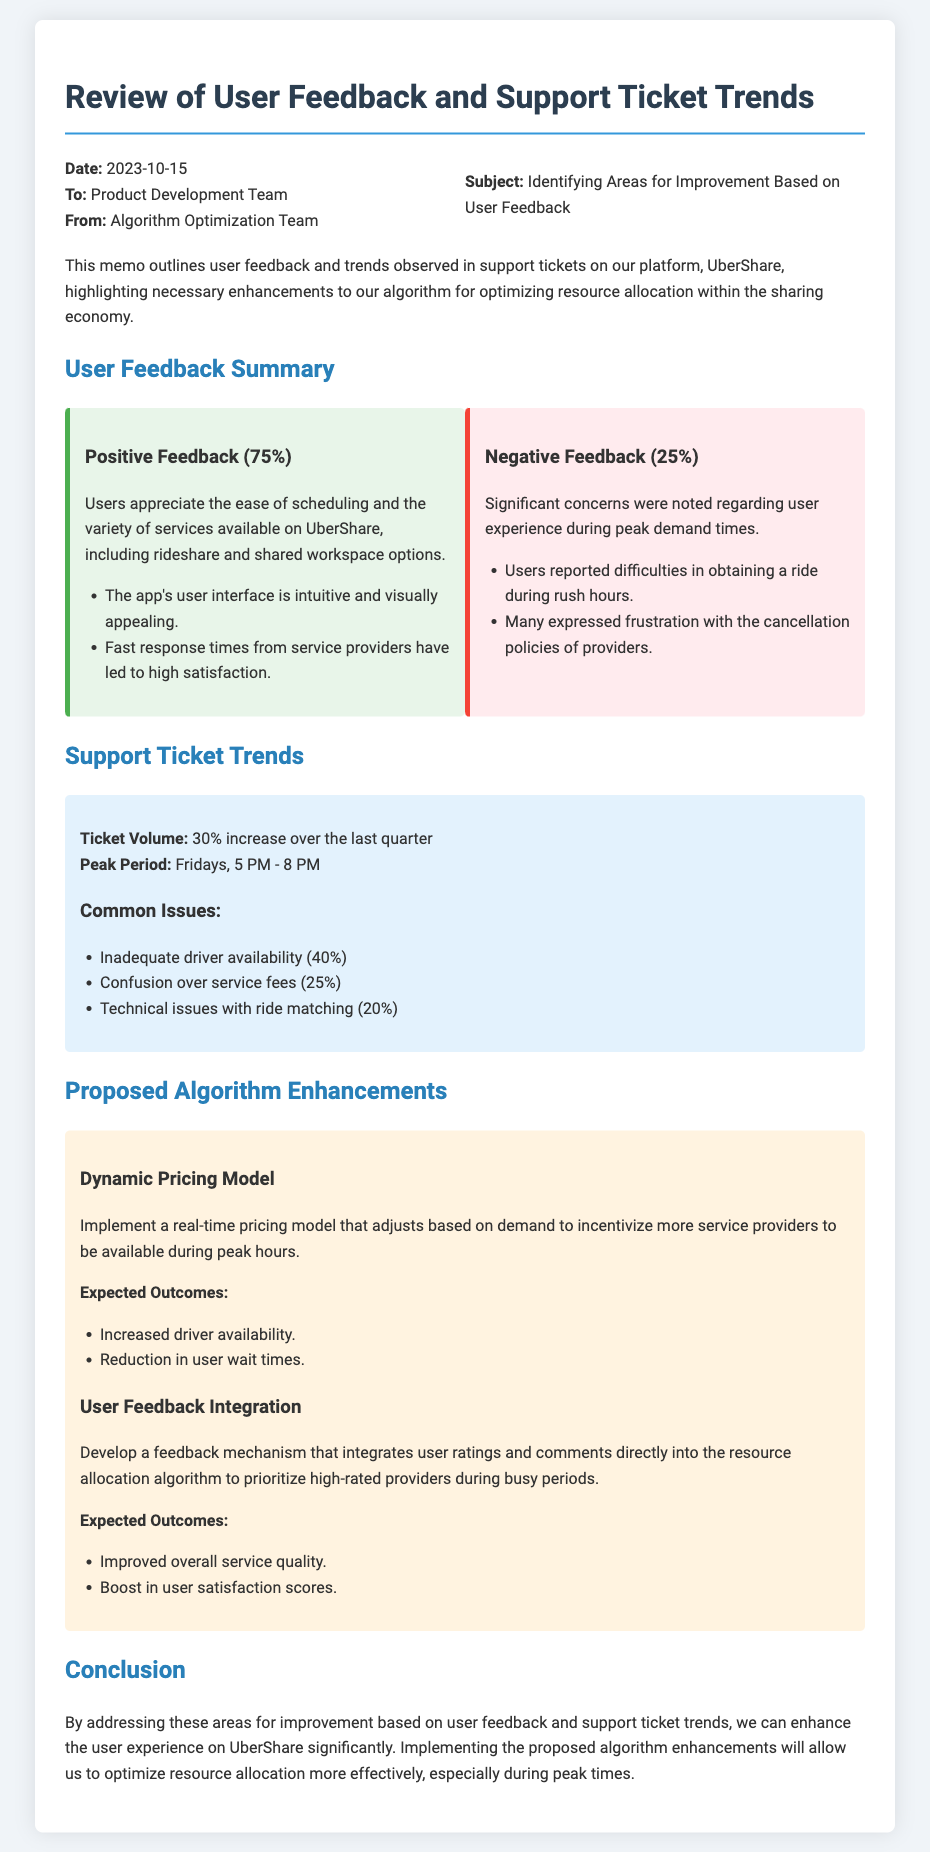What is the date of the memo? The date mentioned in the memo is at the top, stating when it was created.
Answer: 2023-10-15 What is the percentage of positive feedback? The document specifies the percentage of positive feedback from users.
Answer: 75% What are the common issues reported in support tickets? The memo lists the top issues customers reported based on support tickets.
Answer: Inadequate driver availability, confusion over service fees, technical issues with ride matching What is the expected outcome of the dynamic pricing model? The memo details the expected outcomes of implementing the dynamic pricing model.
Answer: Increased driver availability, reduction in user wait times What is the peak period for ticket volume? The document indicates the specific time frame when ticket volume peaks.
Answer: Fridays, 5 PM - 8 PM What is the main focus of this memo? The memo outlines its primary objective regarding user feedback.
Answer: Identifying areas for improvement based on user feedback How much has ticket volume increased over the last quarter? The memo provides specific metrics regarding the ticket volume change.
Answer: 30% increase What is the primary intent behind developing the feedback mechanism? The purpose of the feedback mechanism is described in the proposed enhancements section.
Answer: To integrate user ratings and comments directly into the resource allocation algorithm What department is the memo addressed to? The document indicates the department list to whom the memo is directed.
Answer: Product Development Team 